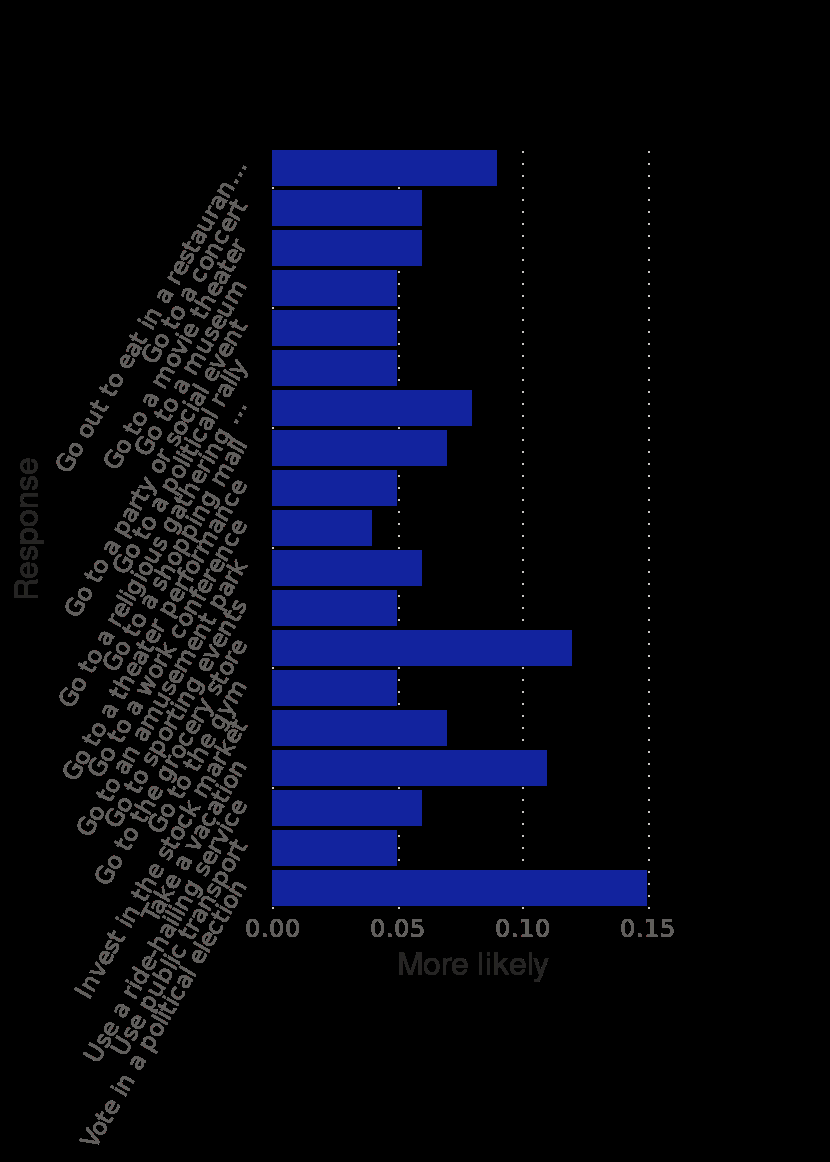<image>
What is the most likely behavioral change among adults?  Voting in a political election. What does the y-axis represent on the bar plot? The y-axis represents the response of U.S. adults likely to change select behaviors if coronavirus (COVID-19) were to spread to their community as of March 1, 2020. What type of plot is used to represent the data? The data is represented using a bar plot. 